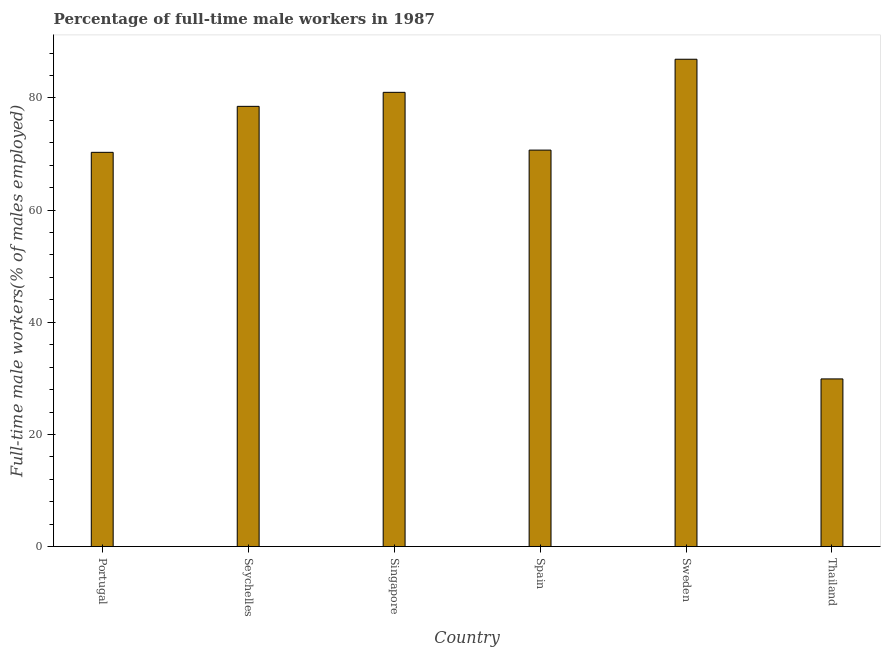Does the graph contain any zero values?
Your answer should be very brief. No. Does the graph contain grids?
Make the answer very short. No. What is the title of the graph?
Make the answer very short. Percentage of full-time male workers in 1987. What is the label or title of the Y-axis?
Offer a very short reply. Full-time male workers(% of males employed). What is the percentage of full-time male workers in Portugal?
Keep it short and to the point. 70.3. Across all countries, what is the maximum percentage of full-time male workers?
Your answer should be very brief. 86.9. Across all countries, what is the minimum percentage of full-time male workers?
Make the answer very short. 29.9. In which country was the percentage of full-time male workers maximum?
Your response must be concise. Sweden. In which country was the percentage of full-time male workers minimum?
Give a very brief answer. Thailand. What is the sum of the percentage of full-time male workers?
Your answer should be very brief. 417.3. What is the average percentage of full-time male workers per country?
Your answer should be very brief. 69.55. What is the median percentage of full-time male workers?
Keep it short and to the point. 74.6. What is the ratio of the percentage of full-time male workers in Singapore to that in Sweden?
Make the answer very short. 0.93. What is the difference between the highest and the second highest percentage of full-time male workers?
Offer a terse response. 5.9. Is the sum of the percentage of full-time male workers in Seychelles and Thailand greater than the maximum percentage of full-time male workers across all countries?
Make the answer very short. Yes. What is the difference between the highest and the lowest percentage of full-time male workers?
Offer a very short reply. 57. Are all the bars in the graph horizontal?
Make the answer very short. No. How many countries are there in the graph?
Your answer should be compact. 6. What is the difference between two consecutive major ticks on the Y-axis?
Offer a terse response. 20. Are the values on the major ticks of Y-axis written in scientific E-notation?
Make the answer very short. No. What is the Full-time male workers(% of males employed) in Portugal?
Your answer should be very brief. 70.3. What is the Full-time male workers(% of males employed) of Seychelles?
Give a very brief answer. 78.5. What is the Full-time male workers(% of males employed) in Singapore?
Offer a terse response. 81. What is the Full-time male workers(% of males employed) of Spain?
Offer a very short reply. 70.7. What is the Full-time male workers(% of males employed) of Sweden?
Give a very brief answer. 86.9. What is the Full-time male workers(% of males employed) in Thailand?
Give a very brief answer. 29.9. What is the difference between the Full-time male workers(% of males employed) in Portugal and Spain?
Your response must be concise. -0.4. What is the difference between the Full-time male workers(% of males employed) in Portugal and Sweden?
Provide a succinct answer. -16.6. What is the difference between the Full-time male workers(% of males employed) in Portugal and Thailand?
Ensure brevity in your answer.  40.4. What is the difference between the Full-time male workers(% of males employed) in Seychelles and Spain?
Your answer should be very brief. 7.8. What is the difference between the Full-time male workers(% of males employed) in Seychelles and Thailand?
Make the answer very short. 48.6. What is the difference between the Full-time male workers(% of males employed) in Singapore and Sweden?
Give a very brief answer. -5.9. What is the difference between the Full-time male workers(% of males employed) in Singapore and Thailand?
Ensure brevity in your answer.  51.1. What is the difference between the Full-time male workers(% of males employed) in Spain and Sweden?
Make the answer very short. -16.2. What is the difference between the Full-time male workers(% of males employed) in Spain and Thailand?
Your answer should be compact. 40.8. What is the difference between the Full-time male workers(% of males employed) in Sweden and Thailand?
Offer a very short reply. 57. What is the ratio of the Full-time male workers(% of males employed) in Portugal to that in Seychelles?
Provide a short and direct response. 0.9. What is the ratio of the Full-time male workers(% of males employed) in Portugal to that in Singapore?
Ensure brevity in your answer.  0.87. What is the ratio of the Full-time male workers(% of males employed) in Portugal to that in Spain?
Give a very brief answer. 0.99. What is the ratio of the Full-time male workers(% of males employed) in Portugal to that in Sweden?
Your response must be concise. 0.81. What is the ratio of the Full-time male workers(% of males employed) in Portugal to that in Thailand?
Keep it short and to the point. 2.35. What is the ratio of the Full-time male workers(% of males employed) in Seychelles to that in Singapore?
Your answer should be compact. 0.97. What is the ratio of the Full-time male workers(% of males employed) in Seychelles to that in Spain?
Offer a very short reply. 1.11. What is the ratio of the Full-time male workers(% of males employed) in Seychelles to that in Sweden?
Provide a short and direct response. 0.9. What is the ratio of the Full-time male workers(% of males employed) in Seychelles to that in Thailand?
Offer a very short reply. 2.62. What is the ratio of the Full-time male workers(% of males employed) in Singapore to that in Spain?
Offer a terse response. 1.15. What is the ratio of the Full-time male workers(% of males employed) in Singapore to that in Sweden?
Offer a very short reply. 0.93. What is the ratio of the Full-time male workers(% of males employed) in Singapore to that in Thailand?
Offer a terse response. 2.71. What is the ratio of the Full-time male workers(% of males employed) in Spain to that in Sweden?
Make the answer very short. 0.81. What is the ratio of the Full-time male workers(% of males employed) in Spain to that in Thailand?
Keep it short and to the point. 2.37. What is the ratio of the Full-time male workers(% of males employed) in Sweden to that in Thailand?
Give a very brief answer. 2.91. 